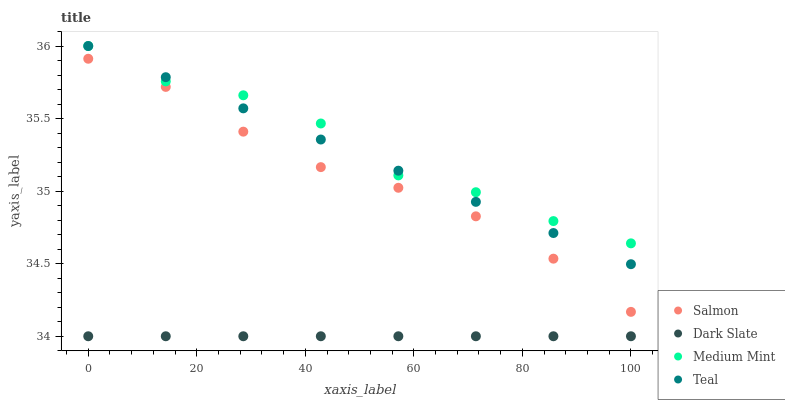Does Dark Slate have the minimum area under the curve?
Answer yes or no. Yes. Does Medium Mint have the maximum area under the curve?
Answer yes or no. Yes. Does Salmon have the minimum area under the curve?
Answer yes or no. No. Does Salmon have the maximum area under the curve?
Answer yes or no. No. Is Dark Slate the smoothest?
Answer yes or no. Yes. Is Medium Mint the roughest?
Answer yes or no. Yes. Is Salmon the smoothest?
Answer yes or no. No. Is Salmon the roughest?
Answer yes or no. No. Does Dark Slate have the lowest value?
Answer yes or no. Yes. Does Salmon have the lowest value?
Answer yes or no. No. Does Teal have the highest value?
Answer yes or no. Yes. Does Salmon have the highest value?
Answer yes or no. No. Is Salmon less than Medium Mint?
Answer yes or no. Yes. Is Medium Mint greater than Dark Slate?
Answer yes or no. Yes. Does Teal intersect Medium Mint?
Answer yes or no. Yes. Is Teal less than Medium Mint?
Answer yes or no. No. Is Teal greater than Medium Mint?
Answer yes or no. No. Does Salmon intersect Medium Mint?
Answer yes or no. No. 